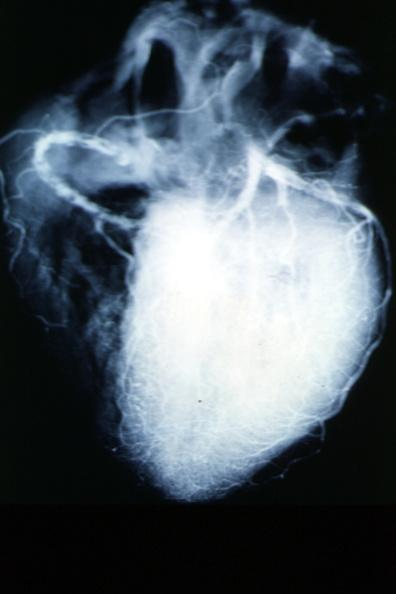what is present?
Answer the question using a single word or phrase. Cardiovascular 